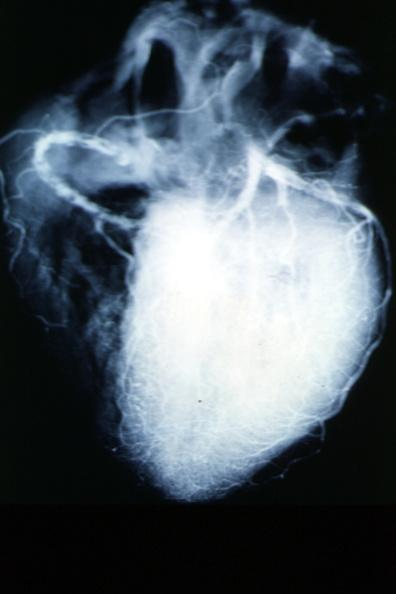what is present?
Answer the question using a single word or phrase. Cardiovascular 